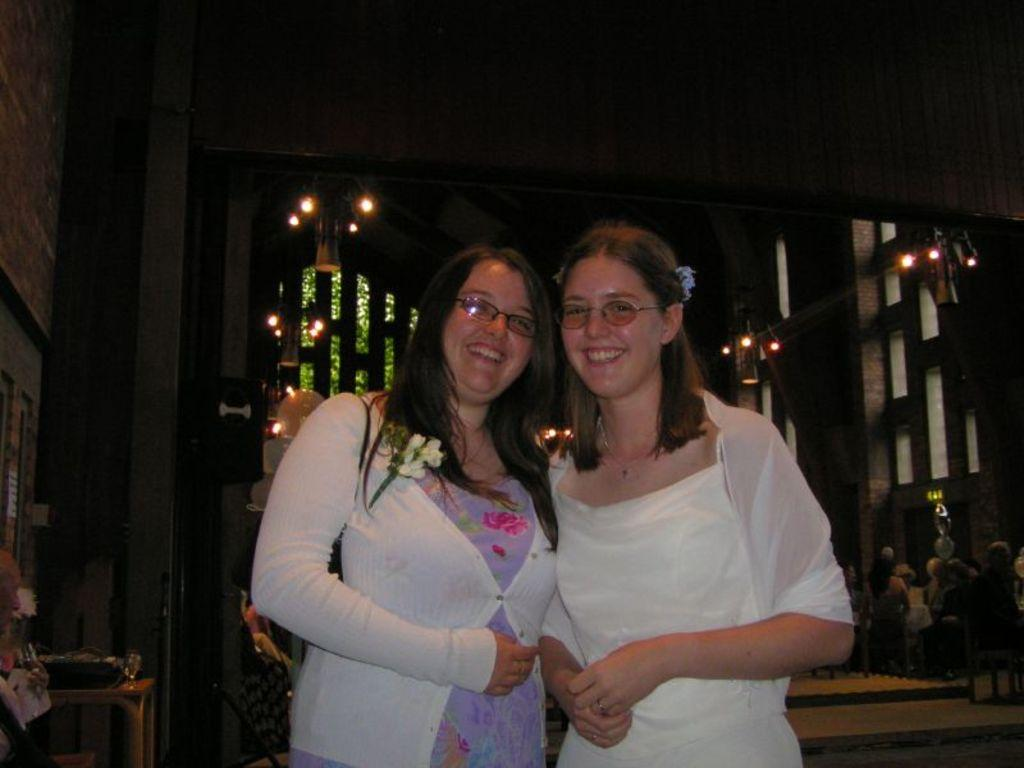How many people are in the image? There are two ladies in the image. What are the ladies doing in the image? The ladies are standing together. What can be seen in the background of the image? There is a building in the background of the image. What type of cookware is being exchanged between the ladies in the image? There is no cookware or exchange of items visible in the image; the ladies are simply standing together. 